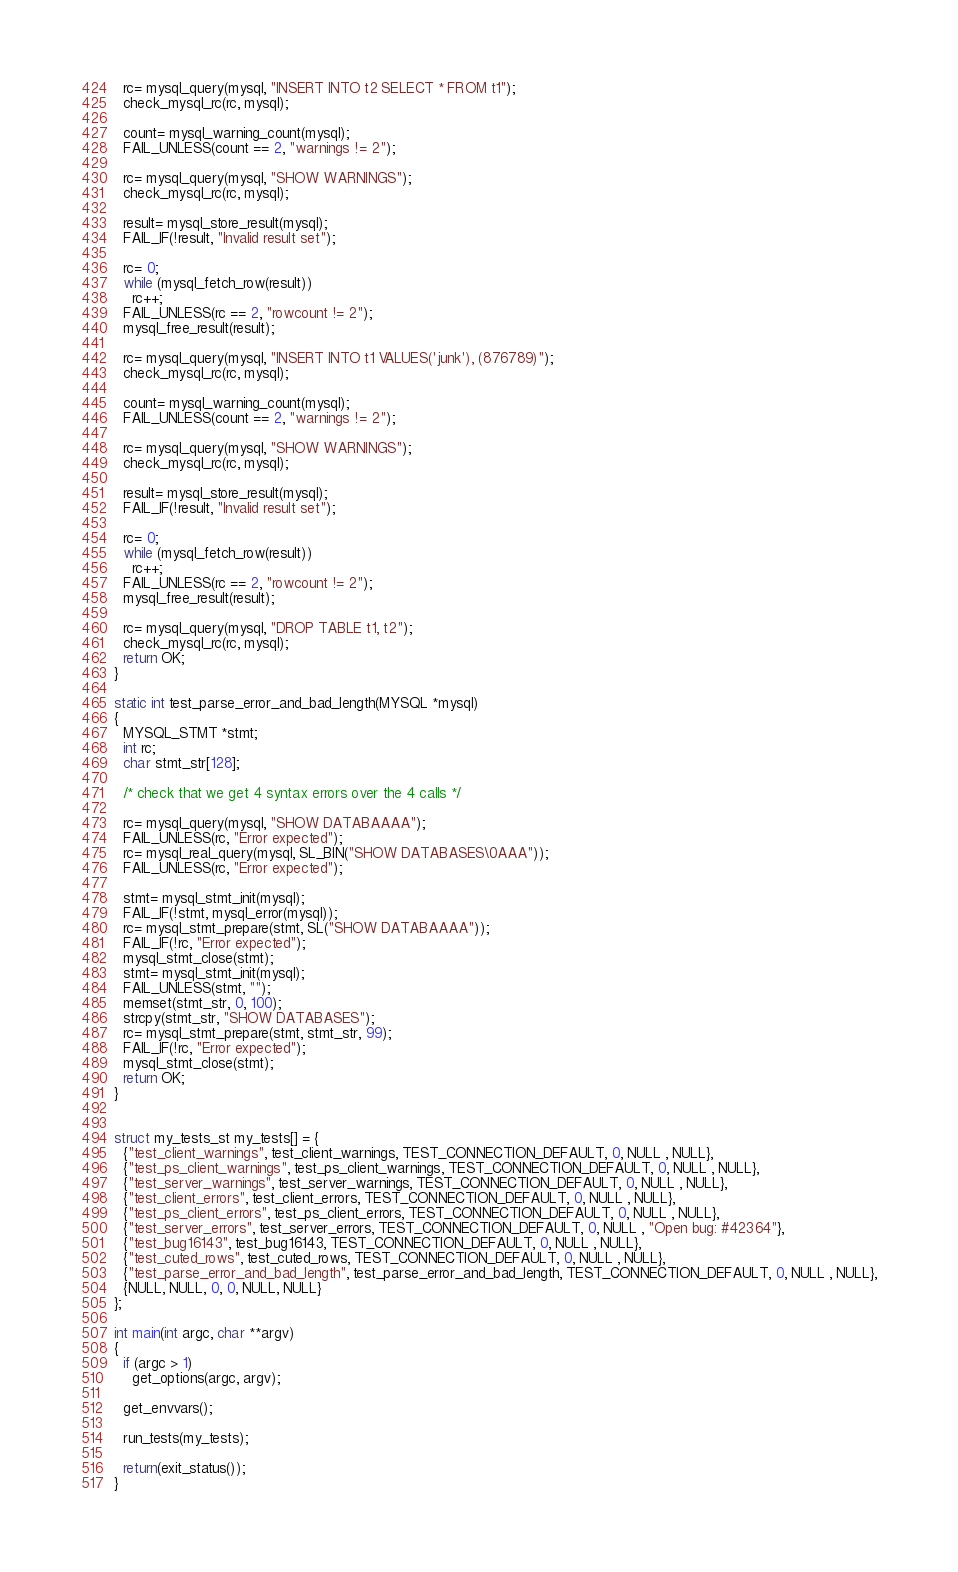<code> <loc_0><loc_0><loc_500><loc_500><_C_>
  rc= mysql_query(mysql, "INSERT INTO t2 SELECT * FROM t1");
  check_mysql_rc(rc, mysql);

  count= mysql_warning_count(mysql);
  FAIL_UNLESS(count == 2, "warnings != 2");

  rc= mysql_query(mysql, "SHOW WARNINGS");
  check_mysql_rc(rc, mysql);

  result= mysql_store_result(mysql);
  FAIL_IF(!result, "Invalid result set");

  rc= 0;
  while (mysql_fetch_row(result))
    rc++;
  FAIL_UNLESS(rc == 2, "rowcount != 2");
  mysql_free_result(result);

  rc= mysql_query(mysql, "INSERT INTO t1 VALUES('junk'), (876789)");
  check_mysql_rc(rc, mysql);

  count= mysql_warning_count(mysql);
  FAIL_UNLESS(count == 2, "warnings != 2");

  rc= mysql_query(mysql, "SHOW WARNINGS");
  check_mysql_rc(rc, mysql);

  result= mysql_store_result(mysql);
  FAIL_IF(!result, "Invalid result set");

  rc= 0;
  while (mysql_fetch_row(result))
    rc++;
  FAIL_UNLESS(rc == 2, "rowcount != 2");
  mysql_free_result(result);

  rc= mysql_query(mysql, "DROP TABLE t1, t2");
  check_mysql_rc(rc, mysql);
  return OK;
}

static int test_parse_error_and_bad_length(MYSQL *mysql)
{
  MYSQL_STMT *stmt;
  int rc;
  char stmt_str[128];

  /* check that we get 4 syntax errors over the 4 calls */

  rc= mysql_query(mysql, "SHOW DATABAAAA");
  FAIL_UNLESS(rc, "Error expected");
  rc= mysql_real_query(mysql, SL_BIN("SHOW DATABASES\0AAA"));
  FAIL_UNLESS(rc, "Error expected");

  stmt= mysql_stmt_init(mysql);
  FAIL_IF(!stmt, mysql_error(mysql));
  rc= mysql_stmt_prepare(stmt, SL("SHOW DATABAAAA"));
  FAIL_IF(!rc, "Error expected");
  mysql_stmt_close(stmt);
  stmt= mysql_stmt_init(mysql);
  FAIL_UNLESS(stmt, "");
  memset(stmt_str, 0, 100);
  strcpy(stmt_str, "SHOW DATABASES");
  rc= mysql_stmt_prepare(stmt, stmt_str, 99);
  FAIL_IF(!rc, "Error expected");
  mysql_stmt_close(stmt);
  return OK;
}


struct my_tests_st my_tests[] = {
  {"test_client_warnings", test_client_warnings, TEST_CONNECTION_DEFAULT, 0, NULL , NULL},
  {"test_ps_client_warnings", test_ps_client_warnings, TEST_CONNECTION_DEFAULT, 0, NULL , NULL},
  {"test_server_warnings", test_server_warnings, TEST_CONNECTION_DEFAULT, 0, NULL , NULL},
  {"test_client_errors", test_client_errors, TEST_CONNECTION_DEFAULT, 0, NULL , NULL},
  {"test_ps_client_errors", test_ps_client_errors, TEST_CONNECTION_DEFAULT, 0, NULL , NULL},
  {"test_server_errors", test_server_errors, TEST_CONNECTION_DEFAULT, 0, NULL , "Open bug: #42364"},
  {"test_bug16143", test_bug16143, TEST_CONNECTION_DEFAULT, 0, NULL , NULL},
  {"test_cuted_rows", test_cuted_rows, TEST_CONNECTION_DEFAULT, 0, NULL , NULL},
  {"test_parse_error_and_bad_length", test_parse_error_and_bad_length, TEST_CONNECTION_DEFAULT, 0, NULL , NULL},
  {NULL, NULL, 0, 0, NULL, NULL}
};

int main(int argc, char **argv)
{
  if (argc > 1)
    get_options(argc, argv);

  get_envvars();

  run_tests(my_tests);

  return(exit_status());
}
</code> 